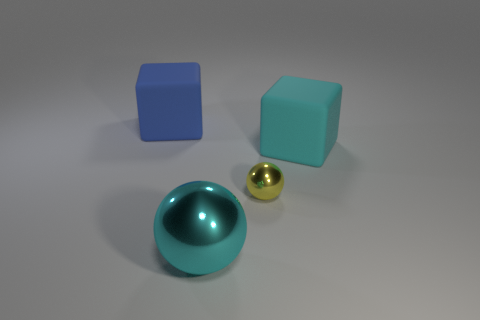Add 3 blue blocks. How many objects exist? 7 Subtract 1 balls. How many balls are left? 1 Subtract all purple blocks. Subtract all green spheres. How many blocks are left? 2 Subtract all yellow blocks. How many brown balls are left? 0 Subtract all cyan metallic things. Subtract all big blue things. How many objects are left? 2 Add 3 tiny yellow things. How many tiny yellow things are left? 4 Add 4 blue matte blocks. How many blue matte blocks exist? 5 Subtract all cyan balls. How many balls are left? 1 Subtract 0 purple blocks. How many objects are left? 4 